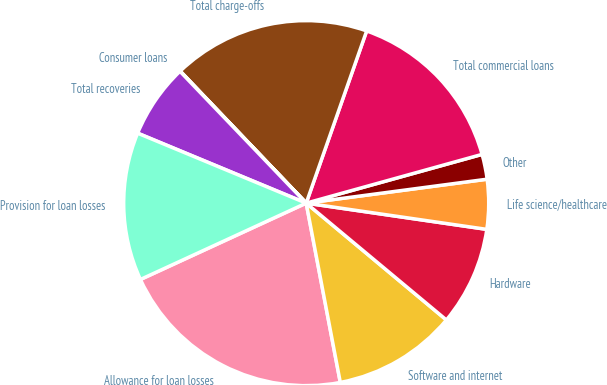Convert chart. <chart><loc_0><loc_0><loc_500><loc_500><pie_chart><fcel>Allowance for loan losses<fcel>Software and internet<fcel>Hardware<fcel>Life science/healthcare<fcel>Other<fcel>Total commercial loans<fcel>Total charge-offs<fcel>Consumer loans<fcel>Total recoveries<fcel>Provision for loan losses<nl><fcel>21.12%<fcel>10.95%<fcel>8.76%<fcel>4.39%<fcel>2.21%<fcel>15.32%<fcel>17.5%<fcel>0.03%<fcel>6.58%<fcel>13.13%<nl></chart> 